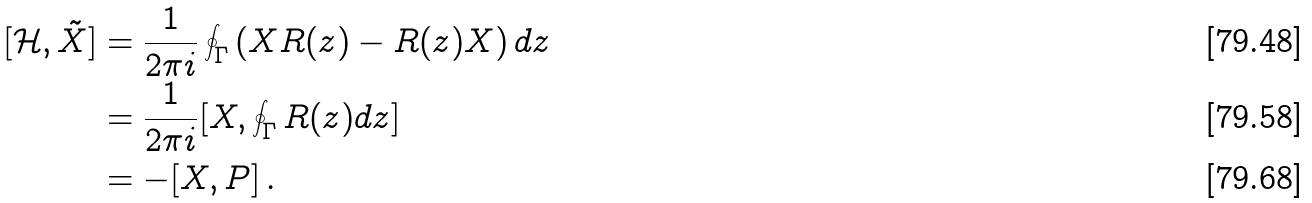Convert formula to latex. <formula><loc_0><loc_0><loc_500><loc_500>[ \mathcal { H } , \tilde { X } ] & = \frac { 1 } { 2 \pi i } \oint _ { \Gamma } \left ( X R ( z ) - R ( z ) X \right ) d z \\ & = \frac { 1 } { 2 \pi i } [ X , \oint _ { \Gamma } R ( z ) d z ] \\ & = - [ X , P ] \, .</formula> 